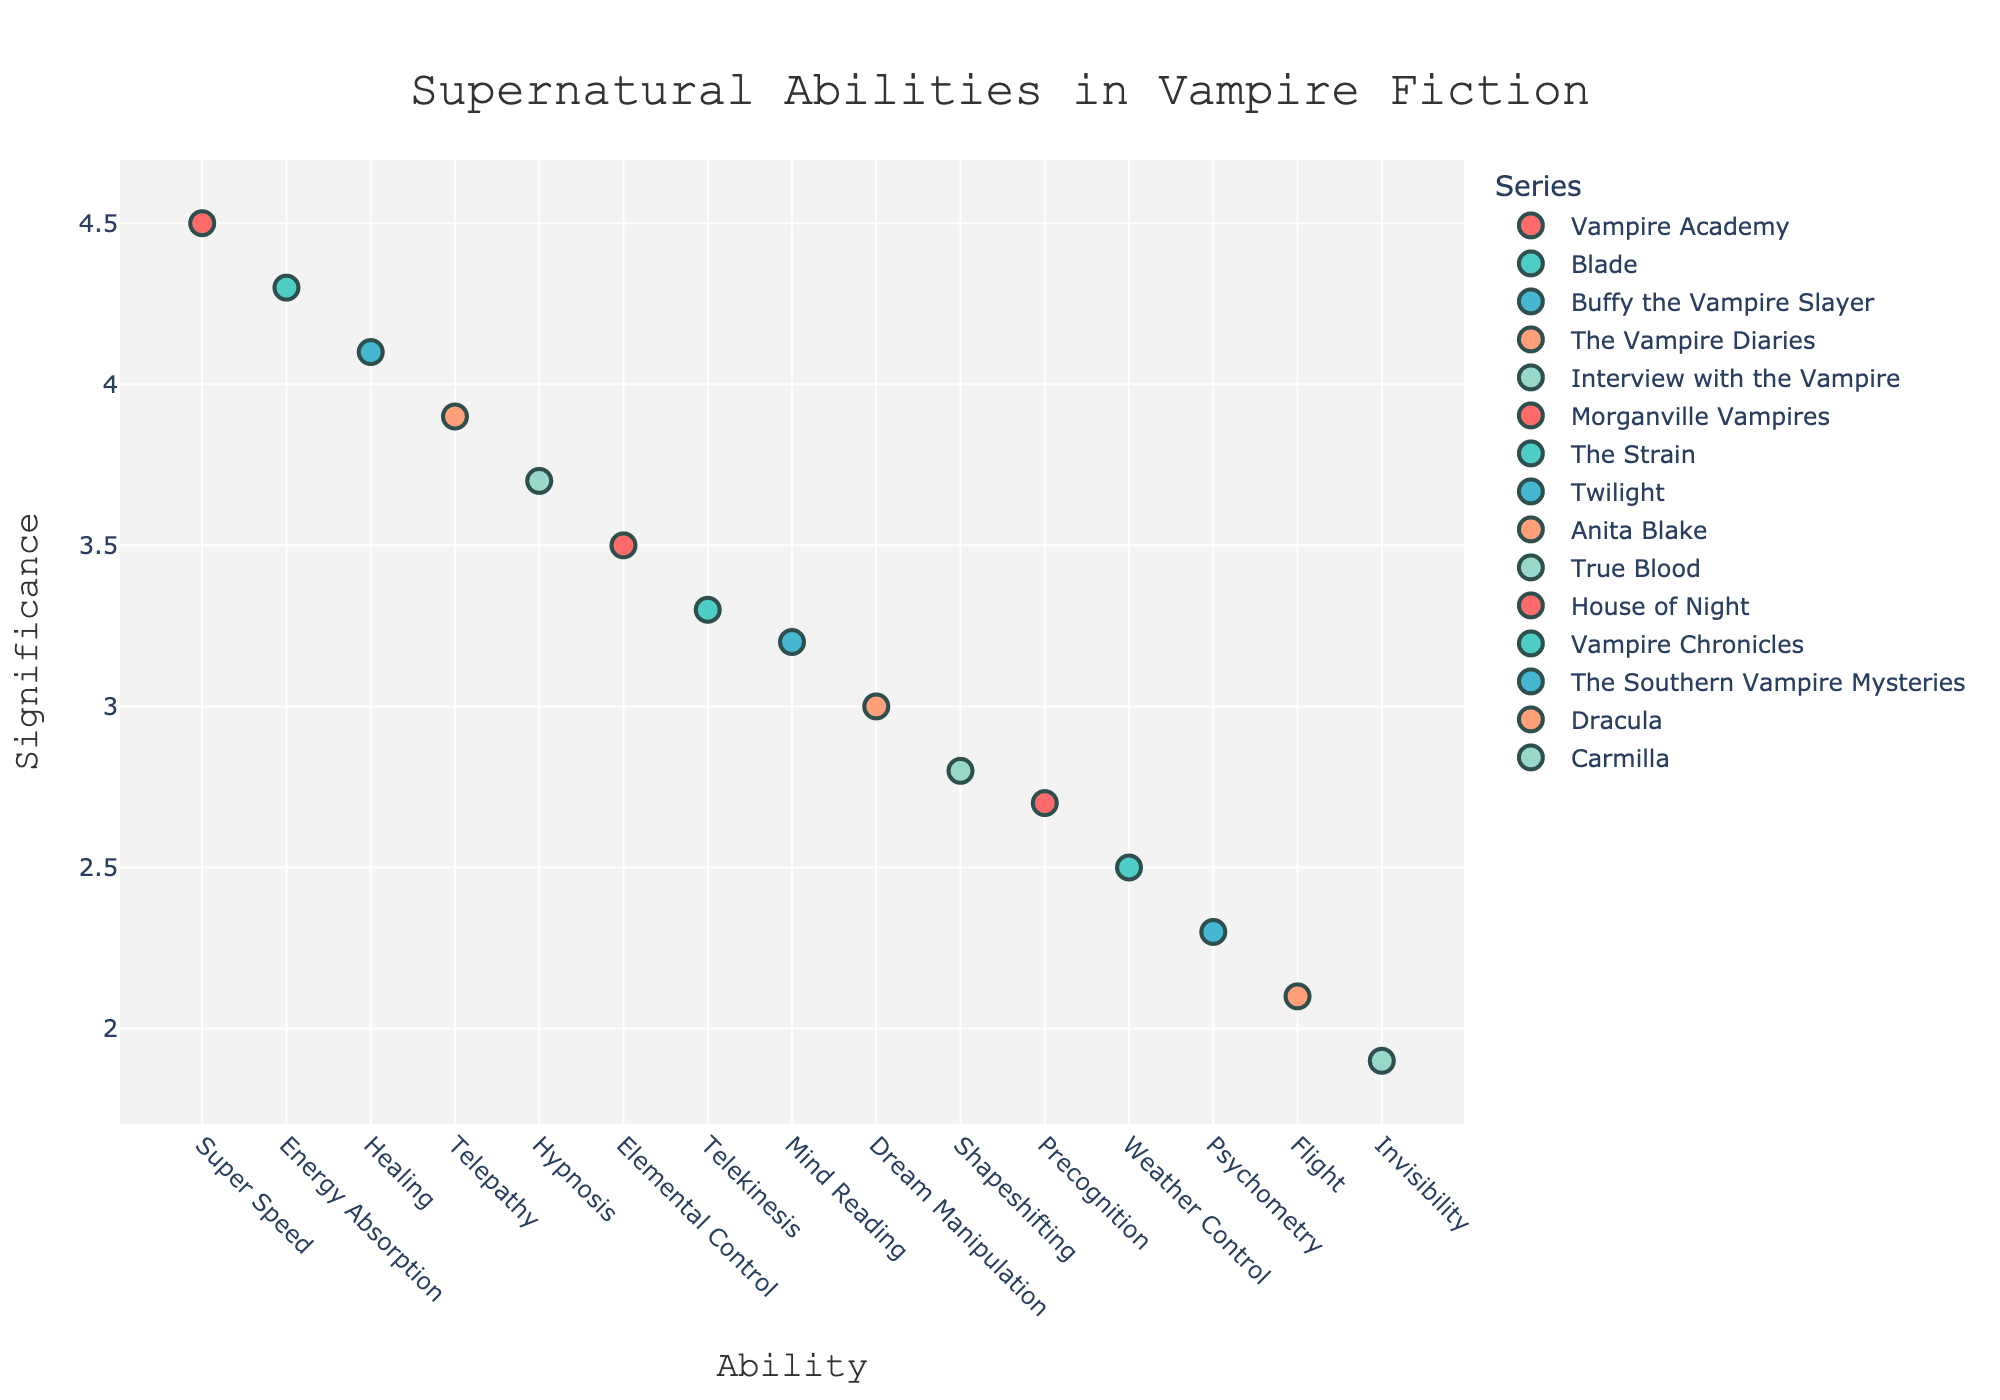What's the title of the plot? The title of the plot is located at the top center of the figure and is written in a larger font.
Answer: Supernatural Abilities in Vampire Fiction How many supernatural abilities are displayed in the plot? The plot displays each supernatural ability as a separate marker. Count the number of unique markers.
Answer: 15 Which series has the highest significance value for any ability? Look for the marker with the highest y-value (Significance) and check the series it belongs to.
Answer: Vampire Academy What is the significance value of Mind Reading in the Twilight series? Find the marker labeled "Mind Reading" and check the y-axis value (Significance) it corresponds to.
Answer: 3.2 Compare the significance values for Healing in Buffy the Vampire Slayer and Telekinesis in The Strain. Which one is higher? Identify the markers for Healing and Telekinesis, compare their y-axis values (Significance).
Answer: Healing Which abilities have a significance value greater than 3.5? Observe the markers above the y-axis value of 3.5 and list their corresponding abilities.
Answer: Super Speed, Telepathy, Healing, Elemental Control, Energy Absorption What is the median significance value of all displayed abilities? Sort the significance values, find the middle value. If the count is even, compute the average of the two middle values.
Answer: 3.2 How many series have at least one ability with a significance value greater than 4? Identify series with markers above the y-axis value of 4. Count the unique series.
Answer: 3 Which ability in Interview with the Vampire is shown in the plot, and what is its significance value? Look for the series named Interview with the Vampire and note the ability and its y-axis value.
Answer: Hypnosis, 3.7 Compare the abilities of Flight in Dracula and Invisibility in Carmilla. Which one has a greater significance value? Find the markers for Flight and Invisibility and compare their y-axis values.
Answer: Flight 